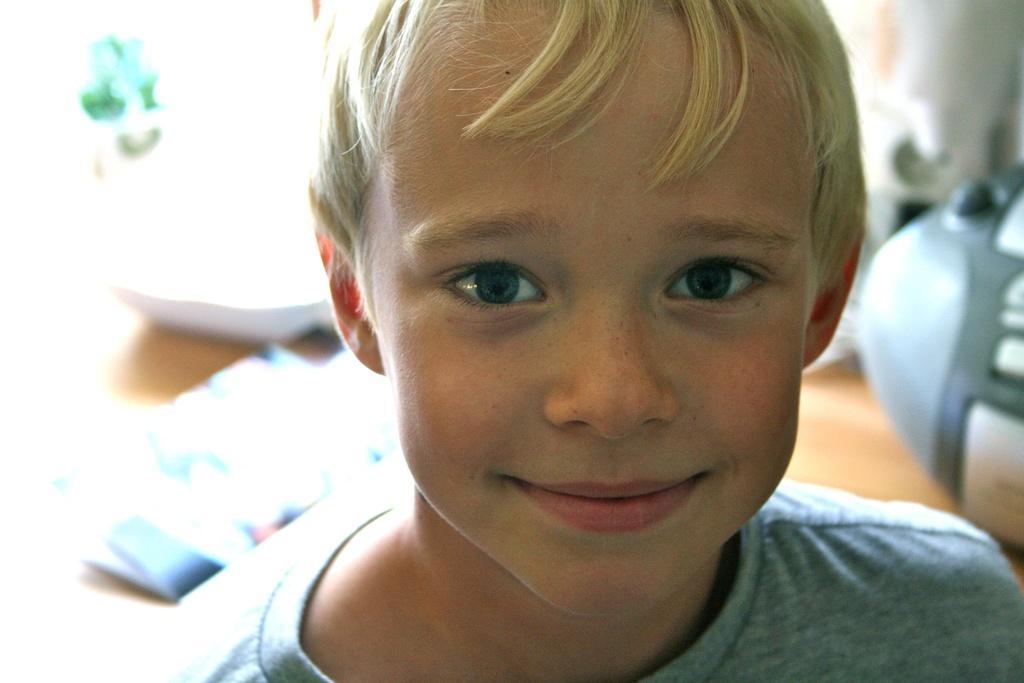Could you give a brief overview of what you see in this image? In the foreground of the picture there is a boy, he smiling. The background is not clear. 